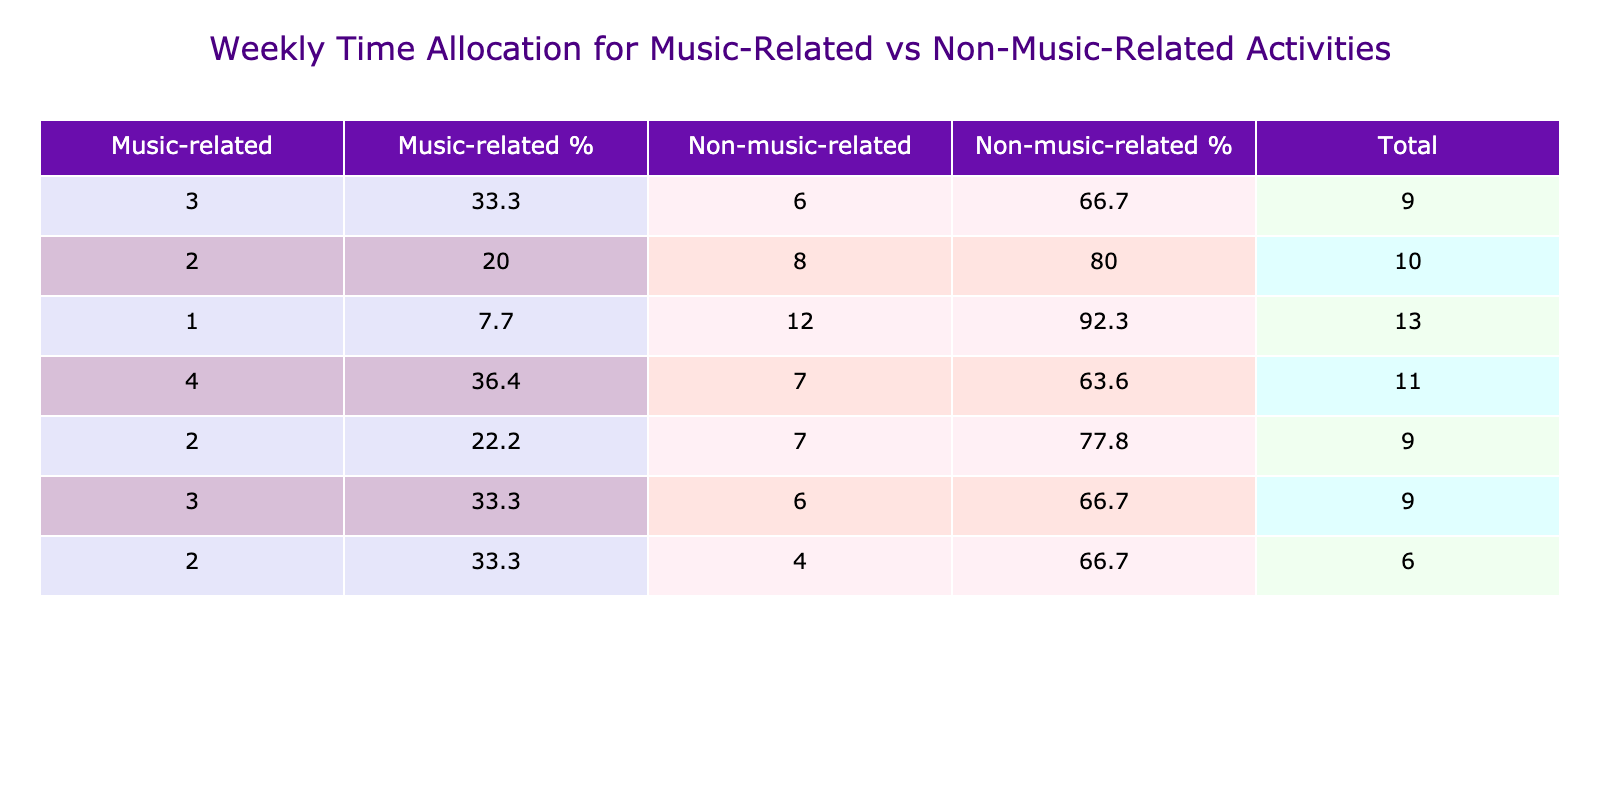What is the total time spent on music-related activities on Saturday? From the table for Saturday, the music-related activities include "Violin practice" (1 hour). Therefore, the total time spent on music-related activities is 1 hour.
Answer: 1 What percentage of total hours on Tuesday is spent on music-related activities? On Tuesday, the total hours are 9 (3 for orchestra rehearsal + 2 for watching TV shows + 3 for hanging out with friends + 1 for reading fiction). The music-related hours are 3. The percentage is (3/9) * 100 = 33.3%.
Answer: 33.3 Did I spend more time on non-music-related activities than music-related activities on Friday? On Friday, I spent 6 hours on non-music-related activities (4 for partying + 2 for social media) and 3 hours on music-related activities (1 for violin lesson + 2 for listening to music). Since 6 is greater than 3, the statement is true.
Answer: Yes What was the average daily time spent on music-related activities across the week? The total hours spent on music-related activities are 12 (2 + 3 + 2 + 1 + 1 + 2 + 3). There are 7 days in a week, so the average is 12/7 = approximately 1.7 hours.
Answer: 1.7 What day had the highest total hours spent? By inspecting the total hours column for each day, Saturday has the highest hours with 13 (5 for movie marathon + 4 for hanging out with friends + 3 for online gaming + 1 for violin practice).
Answer: Saturday What is the difference in hours spent on music-related activities between Monday and Sunday? On Monday, 2 hours were spent on music-related activities, while on Sunday, 4 hours were spent. The difference is 4 - 2 = 2 hours.
Answer: 2 What percentage of the total weekly hours is spent on non-music-related activities? The total weekly hours are 60. Total hours spent on non-music-related activities is 48 (3 + 2 + 3 + 6 + 4 + 12 + 18). The percentage is (48/60) * 100 = 80%.
Answer: 80 Which day had more time spent on social media, Monday or Friday? On Monday, 2 hours were spent on social media, while on Friday, 2 hours were also spent. Thus, the time spent is equal.
Answer: Equal 